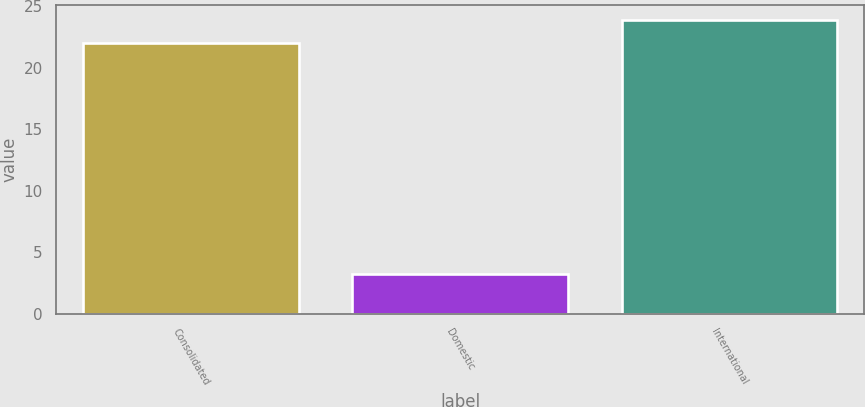Convert chart. <chart><loc_0><loc_0><loc_500><loc_500><bar_chart><fcel>Consolidated<fcel>Domestic<fcel>International<nl><fcel>22<fcel>3.21<fcel>23.88<nl></chart> 